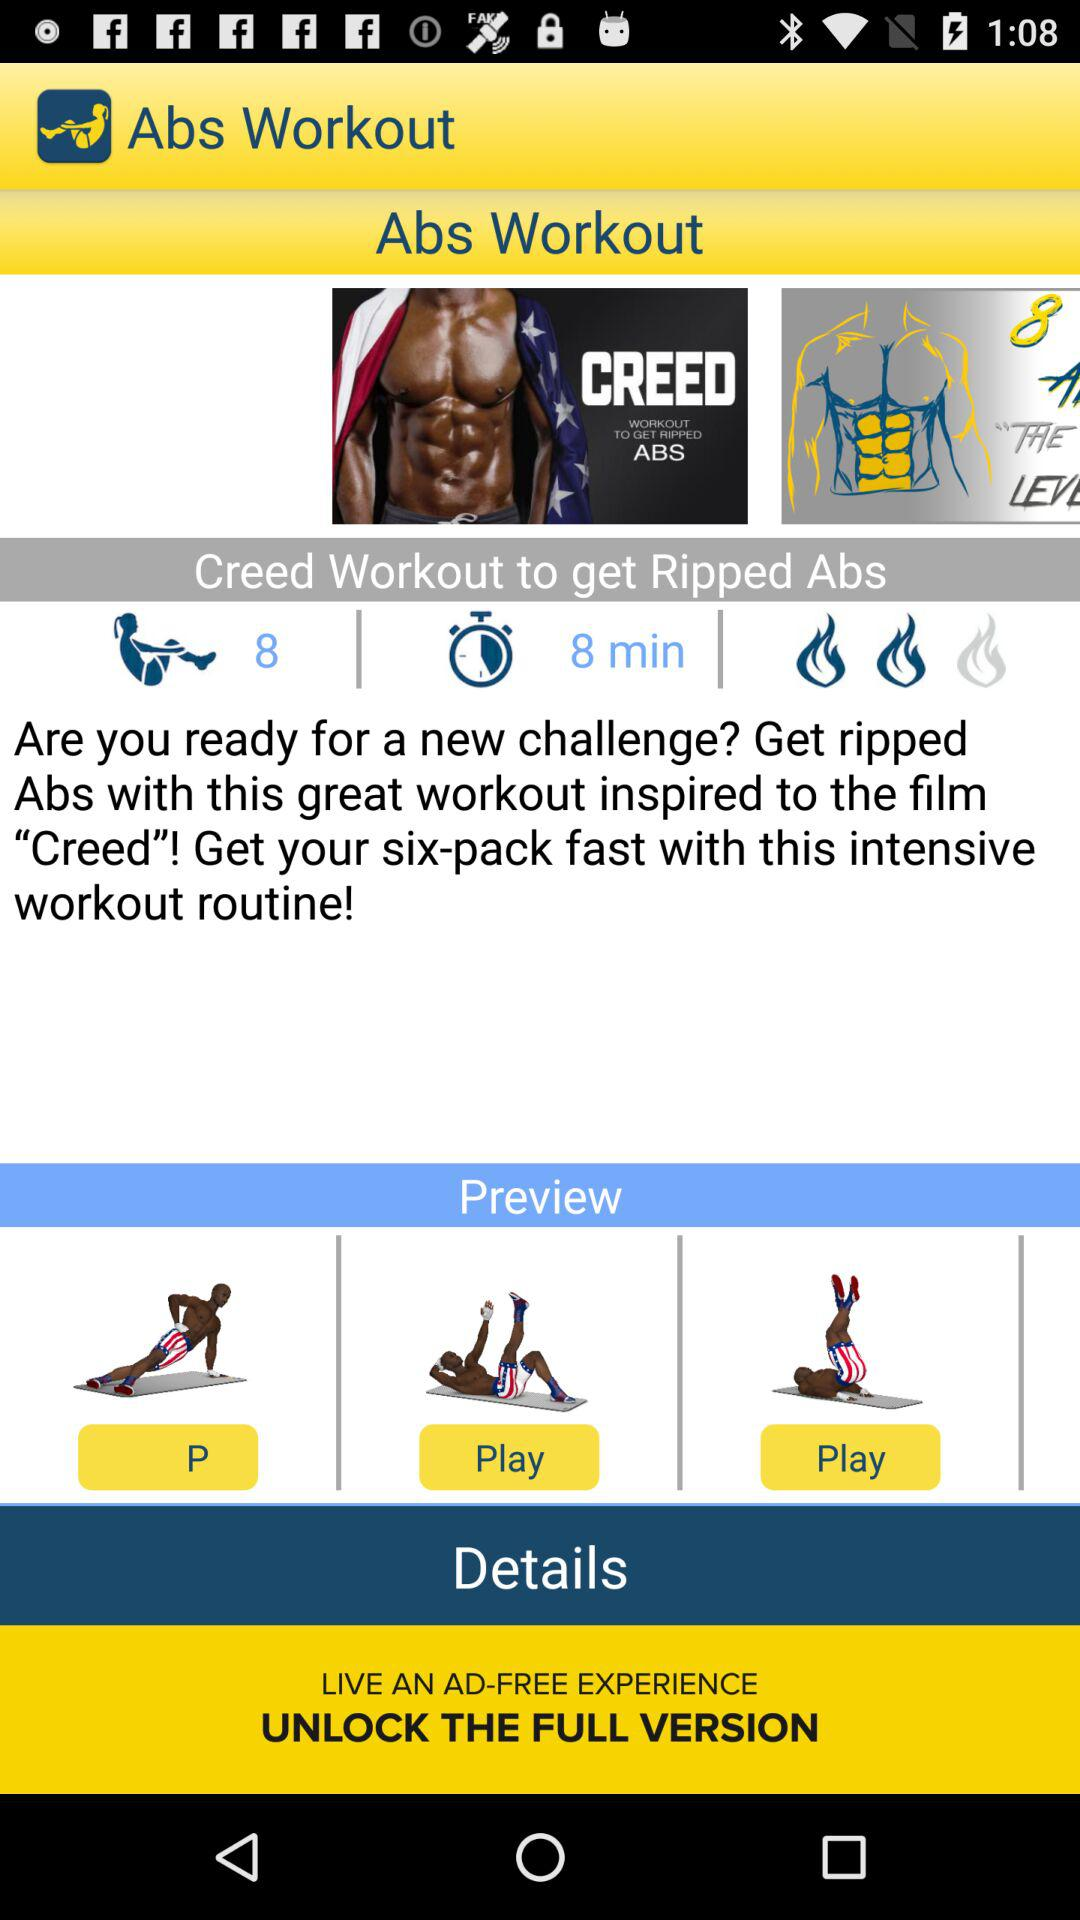What is the description of the details? The description is to live an ad-free experience and unlock the full version. 